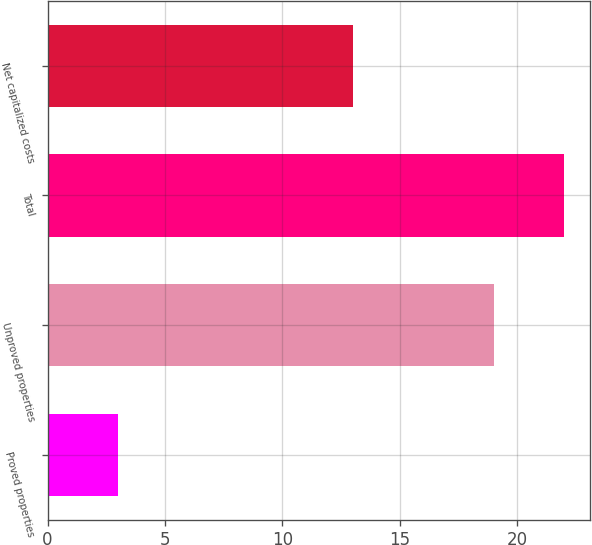<chart> <loc_0><loc_0><loc_500><loc_500><bar_chart><fcel>Proved properties<fcel>Unproved properties<fcel>Total<fcel>Net capitalized costs<nl><fcel>3<fcel>19<fcel>22<fcel>13<nl></chart> 